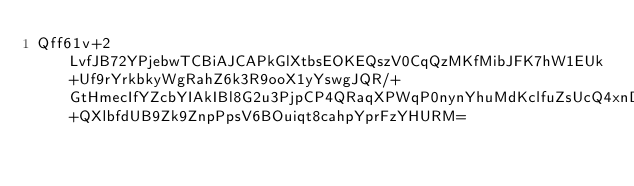<code> <loc_0><loc_0><loc_500><loc_500><_SML_>Qff61v+2LvfJB72YPjebwTCBiAJCAPkGlXtbsEOKEQszV0CqQzMKfMibJFK7hW1EUk+Uf9rYrkbkyWgRahZ6k3R9ooX1yYswgJQR/+GtHmecIfYZcbYIAkIBl8G2u3PjpCP4QRaqXPWqP0nynYhuMdKclfuZsUcQ4xnD6+QXlbfdUB9Zk9ZnpPpsV6BOuiqt8cahpYprFzYHURM=</code> 